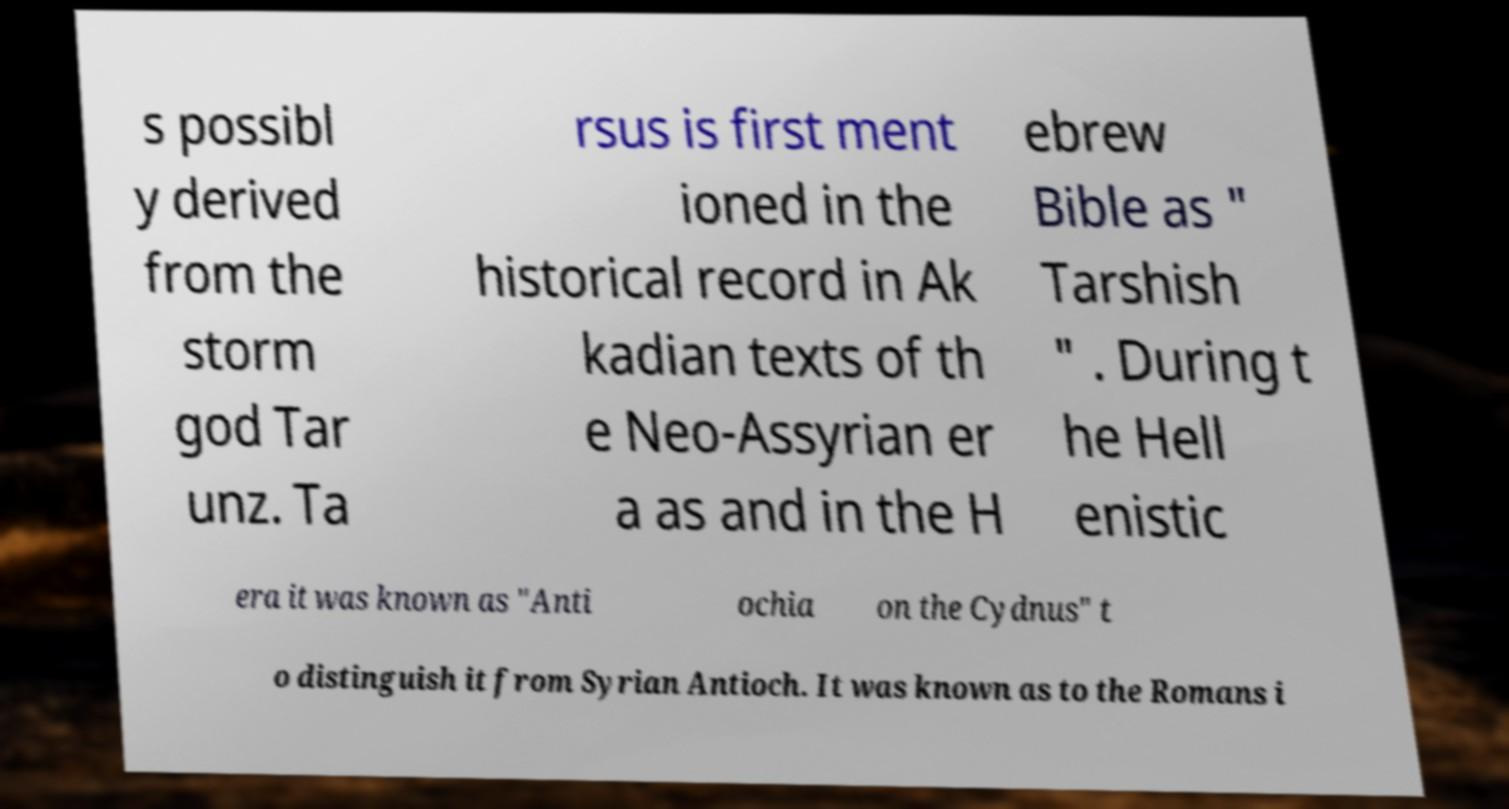Could you assist in decoding the text presented in this image and type it out clearly? s possibl y derived from the storm god Tar unz. Ta rsus is first ment ioned in the historical record in Ak kadian texts of th e Neo-Assyrian er a as and in the H ebrew Bible as " Tarshish " . During t he Hell enistic era it was known as "Anti ochia on the Cydnus" t o distinguish it from Syrian Antioch. It was known as to the Romans i 